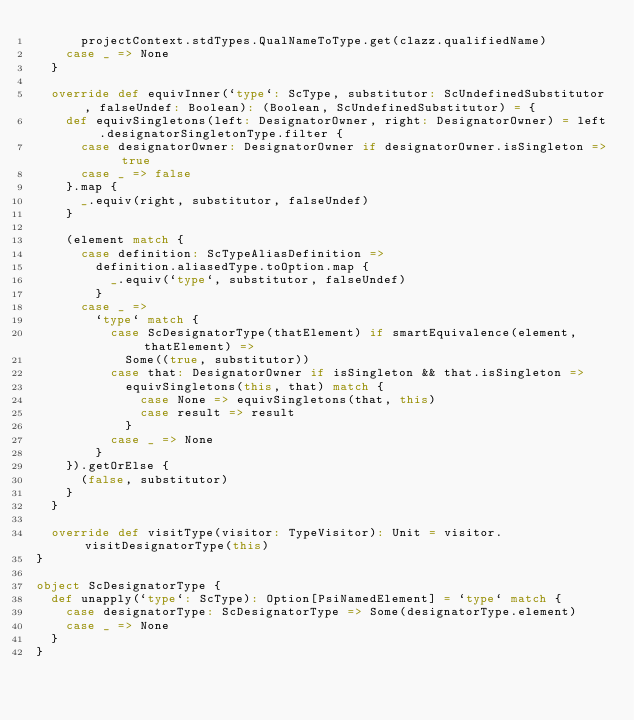Convert code to text. <code><loc_0><loc_0><loc_500><loc_500><_Scala_>      projectContext.stdTypes.QualNameToType.get(clazz.qualifiedName)
    case _ => None
  }

  override def equivInner(`type`: ScType, substitutor: ScUndefinedSubstitutor, falseUndef: Boolean): (Boolean, ScUndefinedSubstitutor) = {
    def equivSingletons(left: DesignatorOwner, right: DesignatorOwner) = left.designatorSingletonType.filter {
      case designatorOwner: DesignatorOwner if designatorOwner.isSingleton => true
      case _ => false
    }.map {
      _.equiv(right, substitutor, falseUndef)
    }

    (element match {
      case definition: ScTypeAliasDefinition =>
        definition.aliasedType.toOption.map {
          _.equiv(`type`, substitutor, falseUndef)
        }
      case _ =>
        `type` match {
          case ScDesignatorType(thatElement) if smartEquivalence(element, thatElement) =>
            Some((true, substitutor))
          case that: DesignatorOwner if isSingleton && that.isSingleton =>
            equivSingletons(this, that) match {
              case None => equivSingletons(that, this)
              case result => result
            }
          case _ => None
        }
    }).getOrElse {
      (false, substitutor)
    }
  }

  override def visitType(visitor: TypeVisitor): Unit = visitor.visitDesignatorType(this)
}

object ScDesignatorType {
  def unapply(`type`: ScType): Option[PsiNamedElement] = `type` match {
    case designatorType: ScDesignatorType => Some(designatorType.element)
    case _ => None
  }
}
</code> 